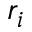Convert formula to latex. <formula><loc_0><loc_0><loc_500><loc_500>r _ { i }</formula> 